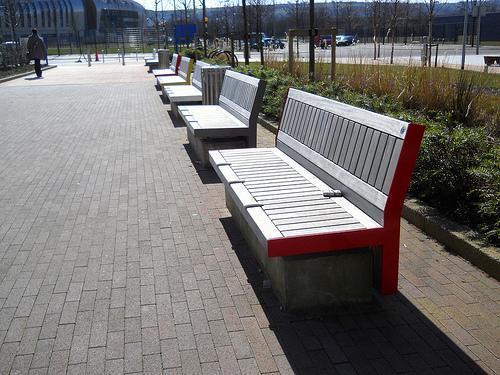How many benches?
Give a very brief answer. 6. 